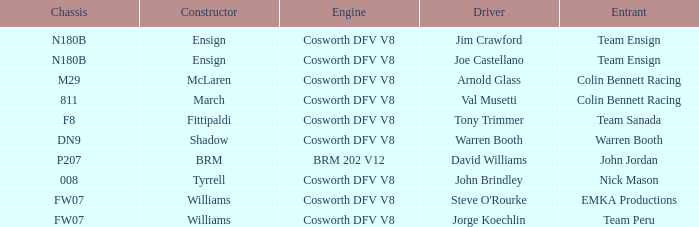What team used the BRM built car? John Jordan. 